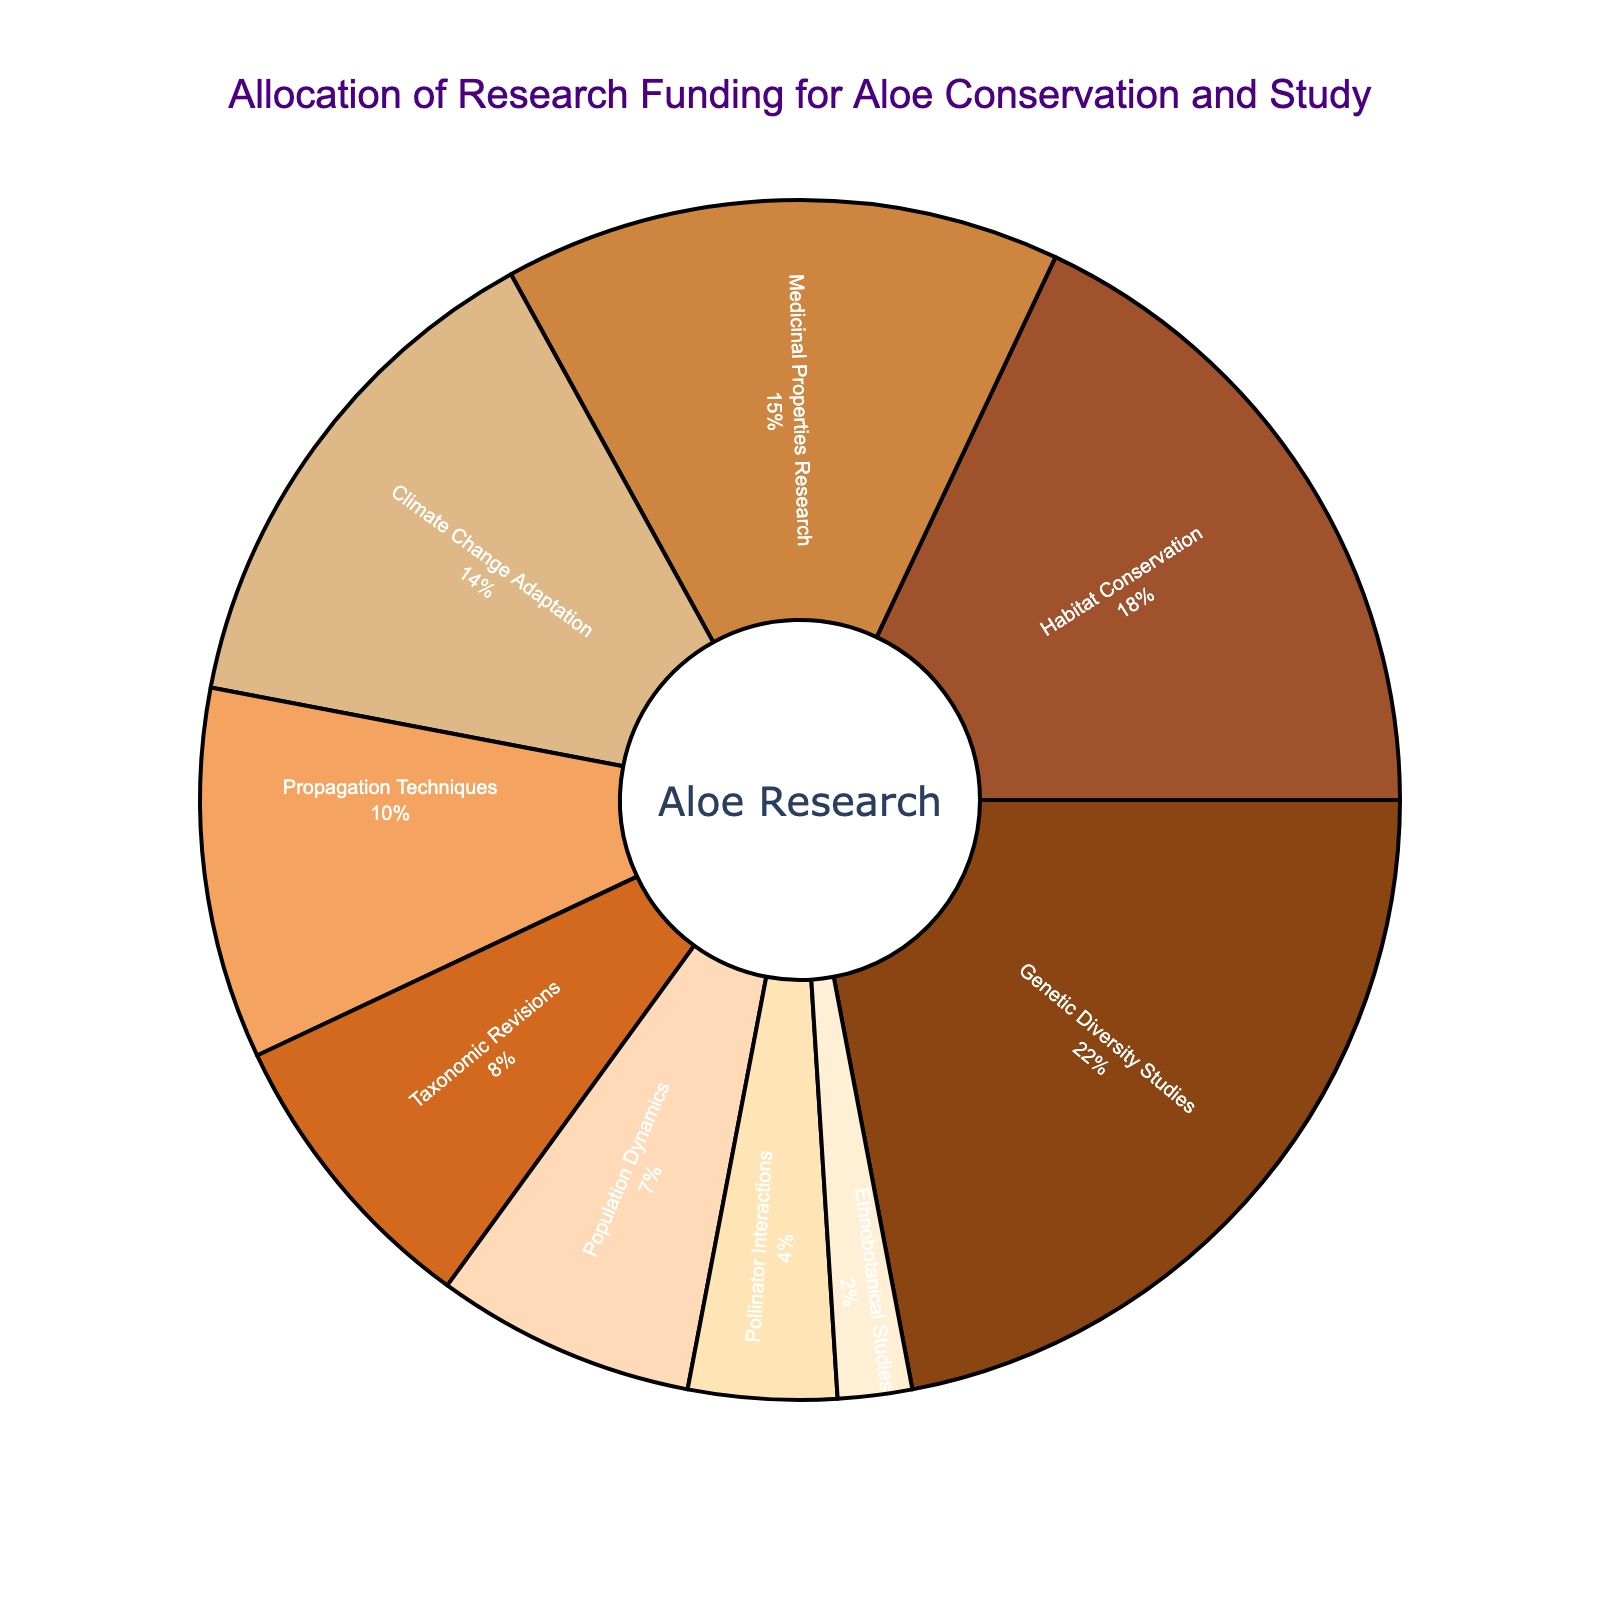What's the total percentage allocation for Genetic Diversity Studies and Habitat Conservation? Add the percentages for Genetic Diversity Studies (22%) and Habitat Conservation (18%) to find the total allocation. 22% + 18% = 40%.
Answer: 40% Which research area received more funding, Medicinal Properties Research or Climate Change Adaptation? Compare the percentages for Medicinal Properties Research (15%) and Climate Change Adaptation (14%). Medicinal Properties Research received more funding.
Answer: Medicinal Properties Research What's the difference in funding allocation between Pollinator Interactions and Ethnobotanical Studies? Subtract the percentage of Ethnobotanical Studies (2%) from Pollinator Interactions (4%). 4% - 2% = 2%.
Answer: 2% Which research area accounts for the smallest portion of the funding? Identify the research area with the smallest percentage in the pie chart, which is Ethnobotanical Studies at 2%.
Answer: Ethnobotanical Studies How much more funding does Propagation Techniques receive compared to Population Dynamics? Subtract the percentage for Population Dynamics (7%) from Propagation Techniques (10%). 10% - 7% = 3%.
Answer: 3% What is the combined funding allocation for Taxonomic Revisions, Population Dynamics, and Pollinator Interactions? Sum the percentages for Taxonomic Revisions (8%), Population Dynamics (7%), and Pollinator Interactions (4%). 8% + 7% + 4% = 19%.
Answer: 19% List the top two research areas in terms of funding allocation. Identify the two research areas with the highest percentages in the pie chart, which are Genetic Diversity Studies (22%) and Habitat Conservation (18%).
Answer: Genetic Diversity Studies and Habitat Conservation Is the funding allocation for Habitat Conservation greater than the combined allocation for Taxonomic Revisions and Population Dynamics? Compare Habitat Conservation's percentage (18%) with the sum of Taxonomic Revisions (8%) and Population Dynamics (7%). 18% > 15% (8% + 7%).
Answer: Yes Which research area has a funding allocation close to 10%? Identify the research area with a percentage close to 10%, which is Propagation Techniques at 10%.
Answer: Propagation Techniques 